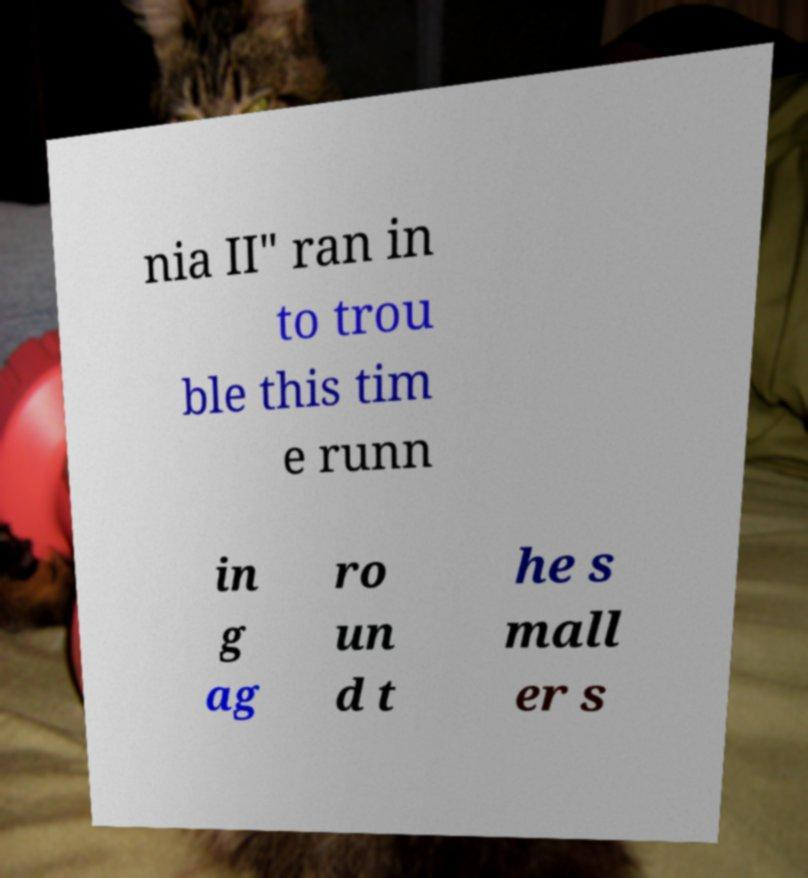Please read and relay the text visible in this image. What does it say? nia II" ran in to trou ble this tim e runn in g ag ro un d t he s mall er s 